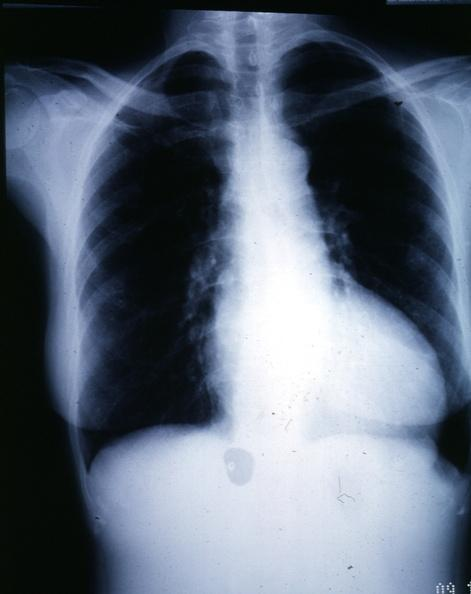where is this from?
Answer the question using a single word or phrase. Heart 